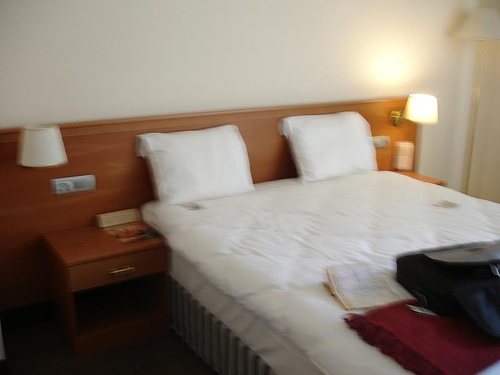<image>Where is the thermostat? I am not sure about the location of the thermostat. It is not clearly visible but could potentially be on the wall or on the headboard. Where is the thermostat? I don't know where the thermostat is located. It can be on the headboard, on the wall, or somewhere else. 